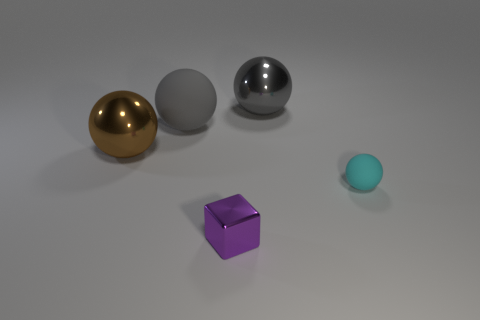Add 4 large rubber things. How many objects exist? 9 Add 3 gray matte cylinders. How many gray matte cylinders exist? 3 Subtract all cyan balls. How many balls are left? 3 Subtract all small cyan rubber spheres. How many spheres are left? 3 Subtract 0 purple balls. How many objects are left? 5 Subtract all balls. How many objects are left? 1 Subtract 1 spheres. How many spheres are left? 3 Subtract all gray blocks. Subtract all green cylinders. How many blocks are left? 1 Subtract all cyan cubes. How many yellow spheres are left? 0 Subtract all gray objects. Subtract all tiny matte cylinders. How many objects are left? 3 